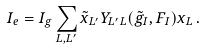Convert formula to latex. <formula><loc_0><loc_0><loc_500><loc_500>I _ { e } = I _ { g } \sum _ { L , L ^ { \prime } } \tilde { x } _ { L ^ { \prime } } Y _ { L ^ { \prime } L } ( \tilde { g } _ { I } , F _ { I } ) x _ { L } \, .</formula> 